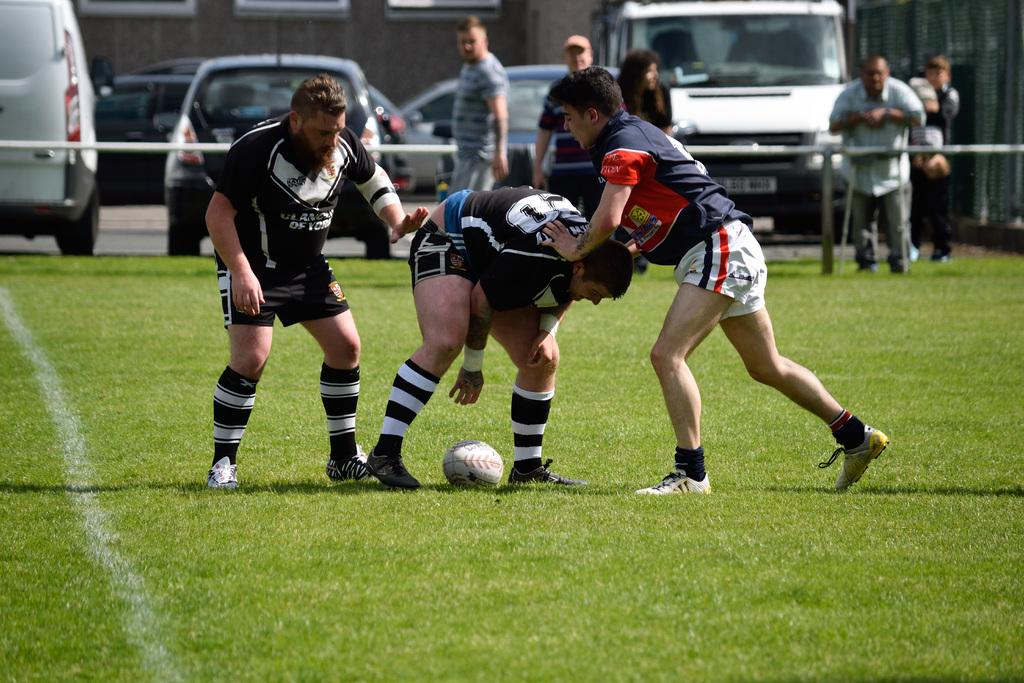What sport are the three men in the image playing? The three men are playing football. What type of clothing are the men wearing while playing football? The men are wearing t-shirts, shorts, and shoes. Are there any other people present in the image? Yes, there are other men observing the sport. What can be seen in the background of the image? There are vehicles parked nearby. What is the total amount of debt owed by the men in the image? There is no information about debt in the image, as it focuses on the men playing football and their clothing. 